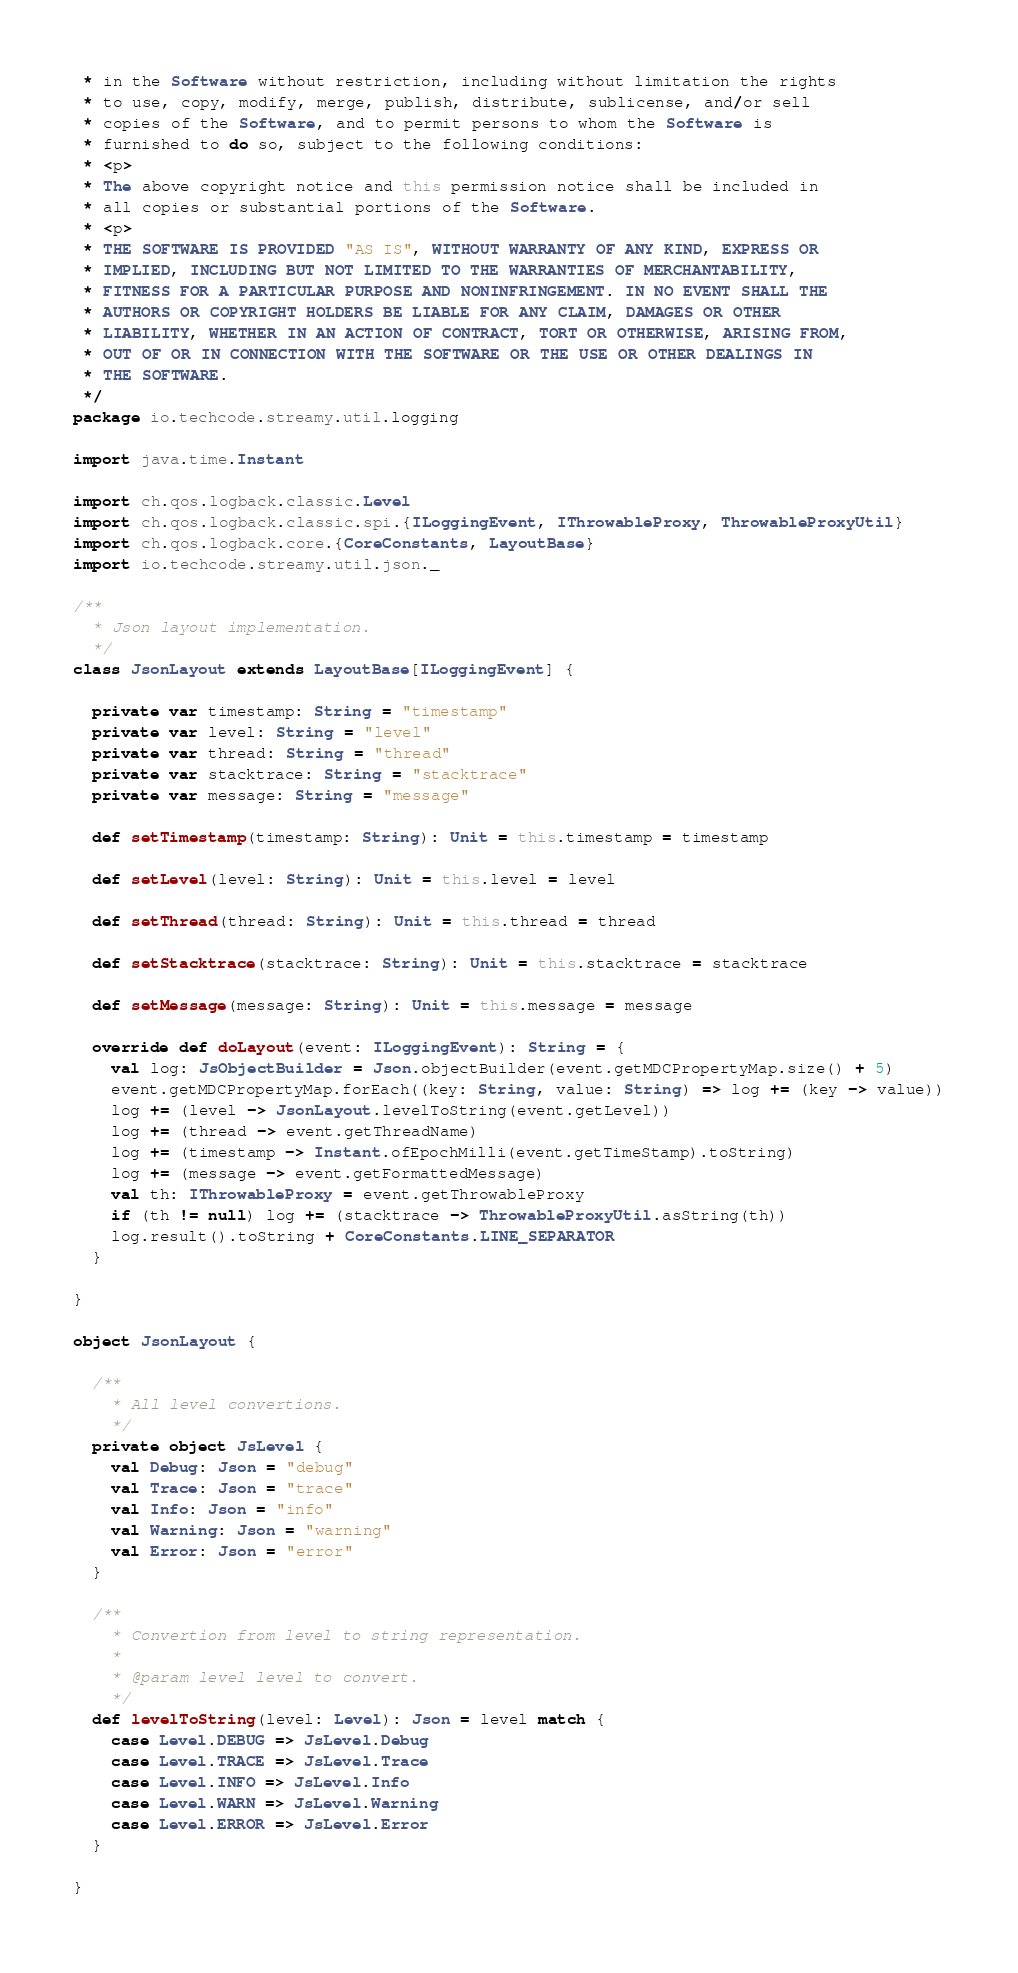<code> <loc_0><loc_0><loc_500><loc_500><_Scala_> * in the Software without restriction, including without limitation the rights
 * to use, copy, modify, merge, publish, distribute, sublicense, and/or sell
 * copies of the Software, and to permit persons to whom the Software is
 * furnished to do so, subject to the following conditions:
 * <p>
 * The above copyright notice and this permission notice shall be included in
 * all copies or substantial portions of the Software.
 * <p>
 * THE SOFTWARE IS PROVIDED "AS IS", WITHOUT WARRANTY OF ANY KIND, EXPRESS OR
 * IMPLIED, INCLUDING BUT NOT LIMITED TO THE WARRANTIES OF MERCHANTABILITY,
 * FITNESS FOR A PARTICULAR PURPOSE AND NONINFRINGEMENT. IN NO EVENT SHALL THE
 * AUTHORS OR COPYRIGHT HOLDERS BE LIABLE FOR ANY CLAIM, DAMAGES OR OTHER
 * LIABILITY, WHETHER IN AN ACTION OF CONTRACT, TORT OR OTHERWISE, ARISING FROM,
 * OUT OF OR IN CONNECTION WITH THE SOFTWARE OR THE USE OR OTHER DEALINGS IN
 * THE SOFTWARE.
 */
package io.techcode.streamy.util.logging

import java.time.Instant

import ch.qos.logback.classic.Level
import ch.qos.logback.classic.spi.{ILoggingEvent, IThrowableProxy, ThrowableProxyUtil}
import ch.qos.logback.core.{CoreConstants, LayoutBase}
import io.techcode.streamy.util.json._

/**
  * Json layout implementation.
  */
class JsonLayout extends LayoutBase[ILoggingEvent] {

  private var timestamp: String = "timestamp"
  private var level: String = "level"
  private var thread: String = "thread"
  private var stacktrace: String = "stacktrace"
  private var message: String = "message"

  def setTimestamp(timestamp: String): Unit = this.timestamp = timestamp

  def setLevel(level: String): Unit = this.level = level

  def setThread(thread: String): Unit = this.thread = thread

  def setStacktrace(stacktrace: String): Unit = this.stacktrace = stacktrace

  def setMessage(message: String): Unit = this.message = message

  override def doLayout(event: ILoggingEvent): String = {
    val log: JsObjectBuilder = Json.objectBuilder(event.getMDCPropertyMap.size() + 5)
    event.getMDCPropertyMap.forEach((key: String, value: String) => log += (key -> value))
    log += (level -> JsonLayout.levelToString(event.getLevel))
    log += (thread -> event.getThreadName)
    log += (timestamp -> Instant.ofEpochMilli(event.getTimeStamp).toString)
    log += (message -> event.getFormattedMessage)
    val th: IThrowableProxy = event.getThrowableProxy
    if (th != null) log += (stacktrace -> ThrowableProxyUtil.asString(th))
    log.result().toString + CoreConstants.LINE_SEPARATOR
  }

}

object JsonLayout {

  /**
    * All level convertions.
    */
  private object JsLevel {
    val Debug: Json = "debug"
    val Trace: Json = "trace"
    val Info: Json = "info"
    val Warning: Json = "warning"
    val Error: Json = "error"
  }

  /**
    * Convertion from level to string representation.
    *
    * @param level level to convert.
    */
  def levelToString(level: Level): Json = level match {
    case Level.DEBUG => JsLevel.Debug
    case Level.TRACE => JsLevel.Trace
    case Level.INFO => JsLevel.Info
    case Level.WARN => JsLevel.Warning
    case Level.ERROR => JsLevel.Error
  }

}
</code> 